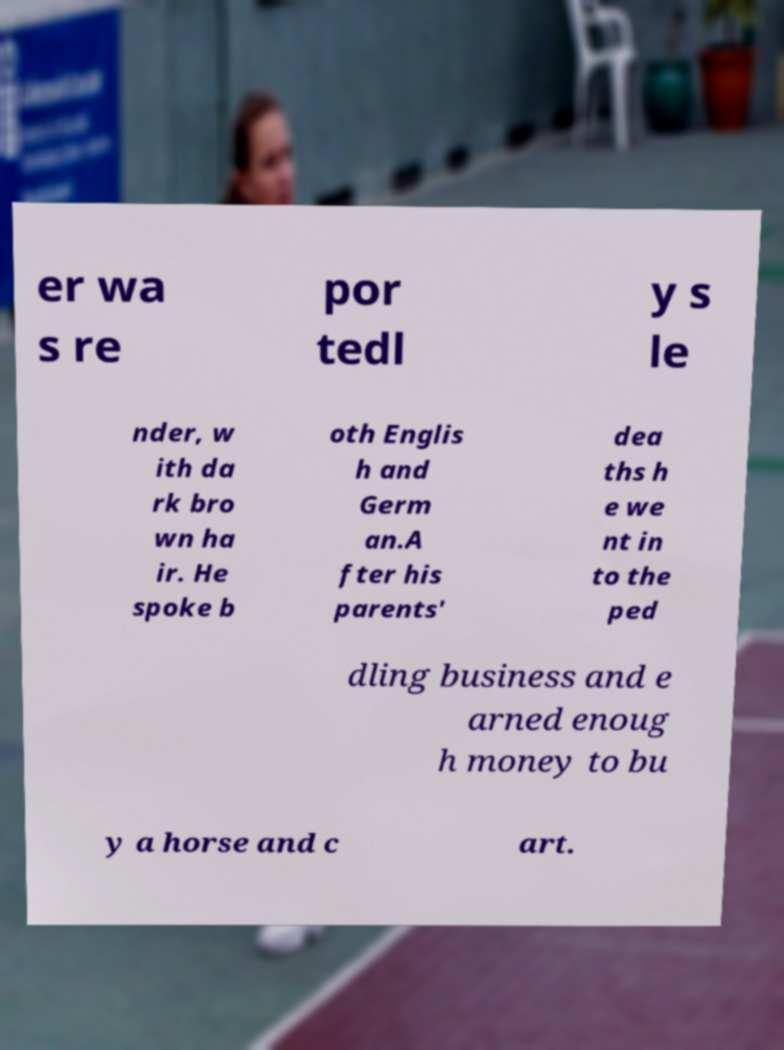Could you assist in decoding the text presented in this image and type it out clearly? er wa s re por tedl y s le nder, w ith da rk bro wn ha ir. He spoke b oth Englis h and Germ an.A fter his parents' dea ths h e we nt in to the ped dling business and e arned enoug h money to bu y a horse and c art. 